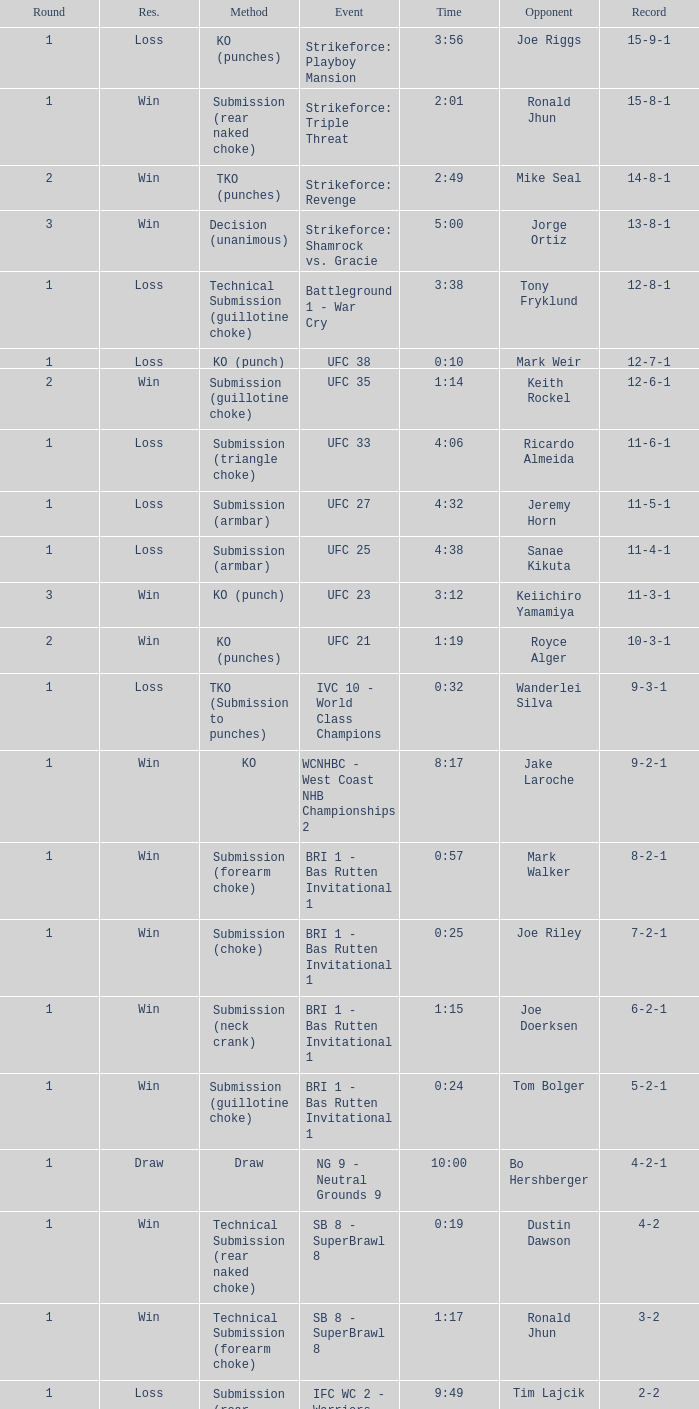Would you mind parsing the complete table? {'header': ['Round', 'Res.', 'Method', 'Event', 'Time', 'Opponent', 'Record'], 'rows': [['1', 'Loss', 'KO (punches)', 'Strikeforce: Playboy Mansion', '3:56', 'Joe Riggs', '15-9-1'], ['1', 'Win', 'Submission (rear naked choke)', 'Strikeforce: Triple Threat', '2:01', 'Ronald Jhun', '15-8-1'], ['2', 'Win', 'TKO (punches)', 'Strikeforce: Revenge', '2:49', 'Mike Seal', '14-8-1'], ['3', 'Win', 'Decision (unanimous)', 'Strikeforce: Shamrock vs. Gracie', '5:00', 'Jorge Ortiz', '13-8-1'], ['1', 'Loss', 'Technical Submission (guillotine choke)', 'Battleground 1 - War Cry', '3:38', 'Tony Fryklund', '12-8-1'], ['1', 'Loss', 'KO (punch)', 'UFC 38', '0:10', 'Mark Weir', '12-7-1'], ['2', 'Win', 'Submission (guillotine choke)', 'UFC 35', '1:14', 'Keith Rockel', '12-6-1'], ['1', 'Loss', 'Submission (triangle choke)', 'UFC 33', '4:06', 'Ricardo Almeida', '11-6-1'], ['1', 'Loss', 'Submission (armbar)', 'UFC 27', '4:32', 'Jeremy Horn', '11-5-1'], ['1', 'Loss', 'Submission (armbar)', 'UFC 25', '4:38', 'Sanae Kikuta', '11-4-1'], ['3', 'Win', 'KO (punch)', 'UFC 23', '3:12', 'Keiichiro Yamamiya', '11-3-1'], ['2', 'Win', 'KO (punches)', 'UFC 21', '1:19', 'Royce Alger', '10-3-1'], ['1', 'Loss', 'TKO (Submission to punches)', 'IVC 10 - World Class Champions', '0:32', 'Wanderlei Silva', '9-3-1'], ['1', 'Win', 'KO', 'WCNHBC - West Coast NHB Championships 2', '8:17', 'Jake Laroche', '9-2-1'], ['1', 'Win', 'Submission (forearm choke)', 'BRI 1 - Bas Rutten Invitational 1', '0:57', 'Mark Walker', '8-2-1'], ['1', 'Win', 'Submission (choke)', 'BRI 1 - Bas Rutten Invitational 1', '0:25', 'Joe Riley', '7-2-1'], ['1', 'Win', 'Submission (neck crank)', 'BRI 1 - Bas Rutten Invitational 1', '1:15', 'Joe Doerksen', '6-2-1'], ['1', 'Win', 'Submission (guillotine choke)', 'BRI 1 - Bas Rutten Invitational 1', '0:24', 'Tom Bolger', '5-2-1'], ['1', 'Draw', 'Draw', 'NG 9 - Neutral Grounds 9', '10:00', 'Bo Hershberger', '4-2-1'], ['1', 'Win', 'Technical Submission (rear naked choke)', 'SB 8 - SuperBrawl 8', '0:19', 'Dustin Dawson', '4-2'], ['1', 'Win', 'Technical Submission (forearm choke)', 'SB 8 - SuperBrawl 8', '1:17', 'Ronald Jhun', '3-2'], ['1', 'Loss', 'Submission (rear naked choke)', 'IFC WC 2 - Warriors Challenge 2', '9:49', 'Tim Lajcik', '2-2'], ['1', 'Win', 'Submission (choke)', 'IFC WC 2 - Warriors Challenge 2', '2:40', 'Mason White', '2-1'], ['1', 'Win', 'Submission (rear naked choke)', 'IFC WC 2 - Warriors Challenge 2', '2:31', 'Toby Oberdine', '1-1'], ['N/A', 'Loss', 'Submission (rear naked choke)', 'IFC WC 1 - Warriors Challenge 1', 'N/A', 'Robbie Kilpatrick', '0-1']]} What was the resolution for the fight against tom bolger by submission (guillotine choke)? Win. 